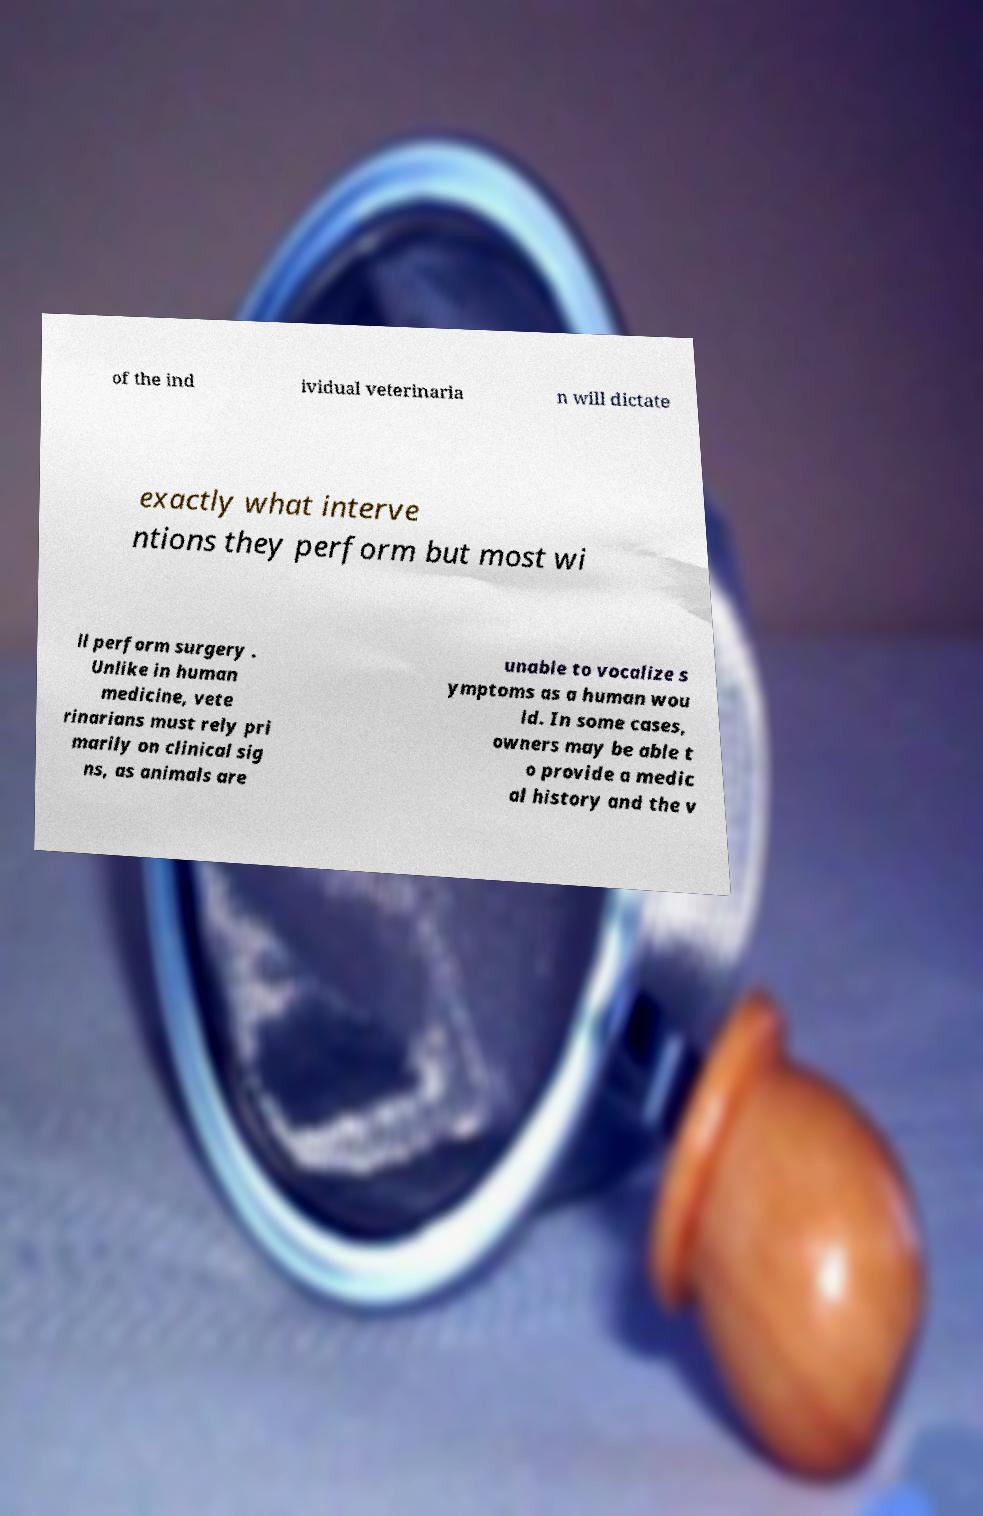I need the written content from this picture converted into text. Can you do that? of the ind ividual veterinaria n will dictate exactly what interve ntions they perform but most wi ll perform surgery . Unlike in human medicine, vete rinarians must rely pri marily on clinical sig ns, as animals are unable to vocalize s ymptoms as a human wou ld. In some cases, owners may be able t o provide a medic al history and the v 